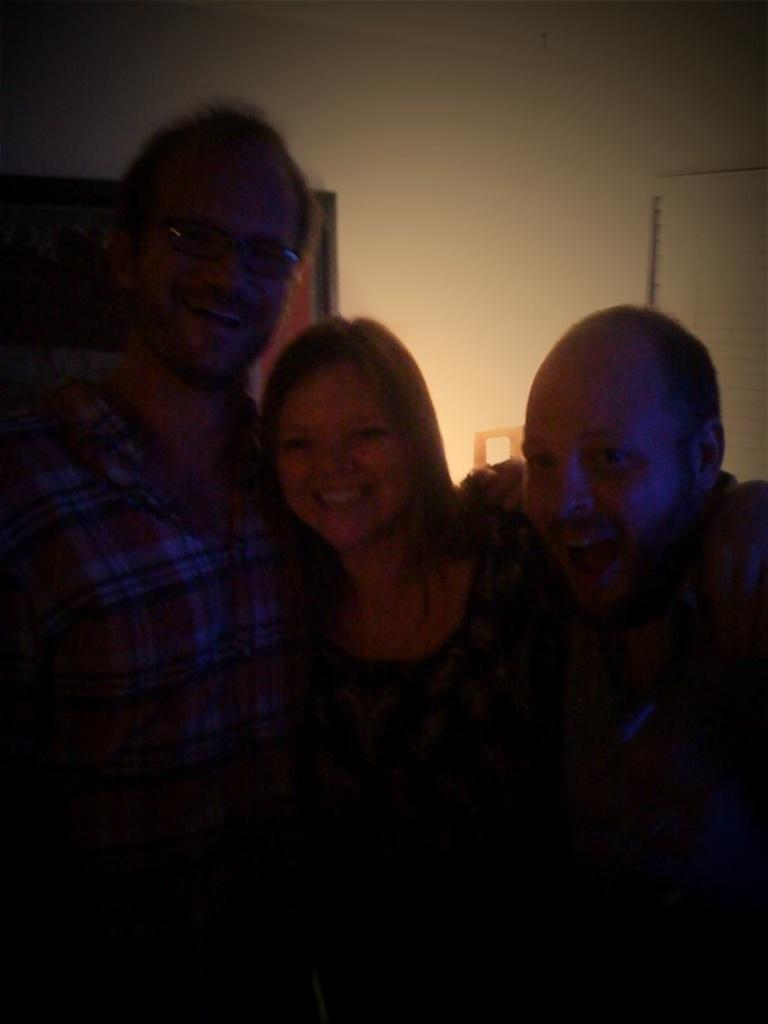How many people are in the image? There are three people in the image. What are the people doing in the image? The people are posing for the camera and smiling. What can be seen in the background of the image? There is a wall in the background of the image. What type of screw can be seen in the image? There is no screw present in the image. Can you describe the cast on the person's arm in the image? There is no cast visible on any person's arm in the image. 